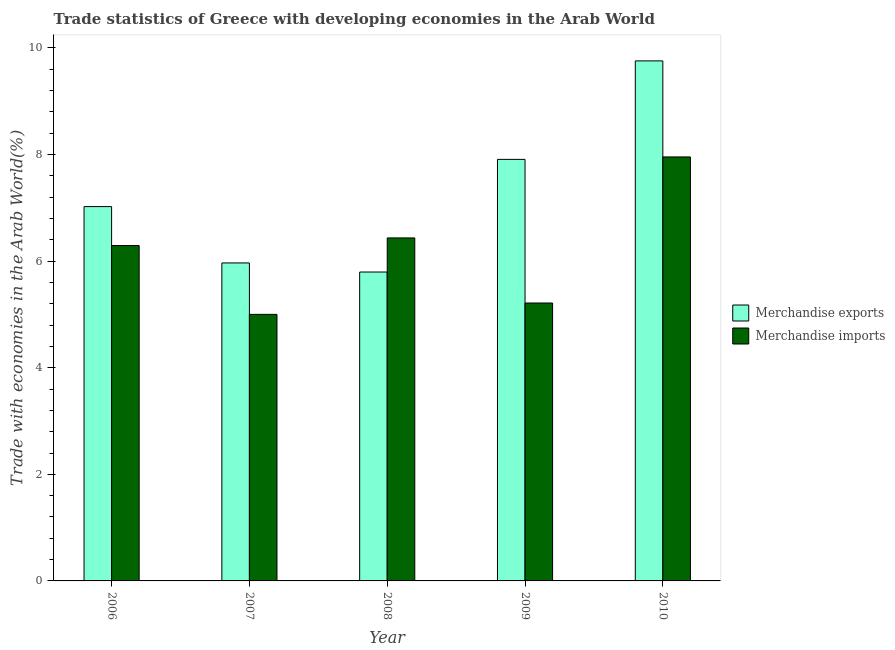How many bars are there on the 2nd tick from the right?
Offer a terse response. 2. What is the merchandise imports in 2006?
Your answer should be compact. 6.29. Across all years, what is the maximum merchandise imports?
Offer a terse response. 7.96. Across all years, what is the minimum merchandise exports?
Your answer should be compact. 5.8. In which year was the merchandise exports maximum?
Offer a very short reply. 2010. What is the total merchandise exports in the graph?
Offer a very short reply. 36.45. What is the difference between the merchandise imports in 2006 and that in 2007?
Provide a short and direct response. 1.29. What is the difference between the merchandise imports in 2006 and the merchandise exports in 2010?
Offer a very short reply. -1.66. What is the average merchandise imports per year?
Your answer should be very brief. 6.18. In the year 2006, what is the difference between the merchandise imports and merchandise exports?
Ensure brevity in your answer.  0. What is the ratio of the merchandise imports in 2006 to that in 2009?
Your answer should be very brief. 1.21. What is the difference between the highest and the second highest merchandise imports?
Offer a terse response. 1.52. What is the difference between the highest and the lowest merchandise exports?
Ensure brevity in your answer.  3.96. In how many years, is the merchandise imports greater than the average merchandise imports taken over all years?
Give a very brief answer. 3. Is the sum of the merchandise imports in 2006 and 2007 greater than the maximum merchandise exports across all years?
Your answer should be compact. Yes. What does the 2nd bar from the left in 2006 represents?
Offer a very short reply. Merchandise imports. What does the 1st bar from the right in 2008 represents?
Your answer should be compact. Merchandise imports. Are all the bars in the graph horizontal?
Keep it short and to the point. No. How many years are there in the graph?
Make the answer very short. 5. What is the difference between two consecutive major ticks on the Y-axis?
Your answer should be compact. 2. Does the graph contain grids?
Ensure brevity in your answer.  No. How are the legend labels stacked?
Your answer should be very brief. Vertical. What is the title of the graph?
Your answer should be very brief. Trade statistics of Greece with developing economies in the Arab World. What is the label or title of the X-axis?
Offer a terse response. Year. What is the label or title of the Y-axis?
Your answer should be very brief. Trade with economies in the Arab World(%). What is the Trade with economies in the Arab World(%) in Merchandise exports in 2006?
Your answer should be compact. 7.02. What is the Trade with economies in the Arab World(%) in Merchandise imports in 2006?
Offer a very short reply. 6.29. What is the Trade with economies in the Arab World(%) in Merchandise exports in 2007?
Your answer should be compact. 5.97. What is the Trade with economies in the Arab World(%) of Merchandise imports in 2007?
Provide a succinct answer. 5. What is the Trade with economies in the Arab World(%) of Merchandise exports in 2008?
Provide a succinct answer. 5.8. What is the Trade with economies in the Arab World(%) in Merchandise imports in 2008?
Your answer should be compact. 6.44. What is the Trade with economies in the Arab World(%) of Merchandise exports in 2009?
Give a very brief answer. 7.91. What is the Trade with economies in the Arab World(%) in Merchandise imports in 2009?
Offer a very short reply. 5.21. What is the Trade with economies in the Arab World(%) of Merchandise exports in 2010?
Your answer should be compact. 9.76. What is the Trade with economies in the Arab World(%) of Merchandise imports in 2010?
Offer a terse response. 7.96. Across all years, what is the maximum Trade with economies in the Arab World(%) of Merchandise exports?
Your answer should be very brief. 9.76. Across all years, what is the maximum Trade with economies in the Arab World(%) of Merchandise imports?
Give a very brief answer. 7.96. Across all years, what is the minimum Trade with economies in the Arab World(%) in Merchandise exports?
Provide a succinct answer. 5.8. Across all years, what is the minimum Trade with economies in the Arab World(%) in Merchandise imports?
Provide a short and direct response. 5. What is the total Trade with economies in the Arab World(%) in Merchandise exports in the graph?
Provide a succinct answer. 36.45. What is the total Trade with economies in the Arab World(%) of Merchandise imports in the graph?
Your answer should be compact. 30.9. What is the difference between the Trade with economies in the Arab World(%) of Merchandise exports in 2006 and that in 2007?
Your response must be concise. 1.06. What is the difference between the Trade with economies in the Arab World(%) of Merchandise imports in 2006 and that in 2007?
Make the answer very short. 1.29. What is the difference between the Trade with economies in the Arab World(%) in Merchandise exports in 2006 and that in 2008?
Offer a terse response. 1.23. What is the difference between the Trade with economies in the Arab World(%) in Merchandise imports in 2006 and that in 2008?
Ensure brevity in your answer.  -0.14. What is the difference between the Trade with economies in the Arab World(%) of Merchandise exports in 2006 and that in 2009?
Offer a very short reply. -0.89. What is the difference between the Trade with economies in the Arab World(%) of Merchandise imports in 2006 and that in 2009?
Give a very brief answer. 1.08. What is the difference between the Trade with economies in the Arab World(%) in Merchandise exports in 2006 and that in 2010?
Provide a short and direct response. -2.73. What is the difference between the Trade with economies in the Arab World(%) of Merchandise imports in 2006 and that in 2010?
Make the answer very short. -1.66. What is the difference between the Trade with economies in the Arab World(%) of Merchandise exports in 2007 and that in 2008?
Make the answer very short. 0.17. What is the difference between the Trade with economies in the Arab World(%) of Merchandise imports in 2007 and that in 2008?
Give a very brief answer. -1.43. What is the difference between the Trade with economies in the Arab World(%) in Merchandise exports in 2007 and that in 2009?
Provide a succinct answer. -1.94. What is the difference between the Trade with economies in the Arab World(%) of Merchandise imports in 2007 and that in 2009?
Give a very brief answer. -0.21. What is the difference between the Trade with economies in the Arab World(%) of Merchandise exports in 2007 and that in 2010?
Your answer should be very brief. -3.79. What is the difference between the Trade with economies in the Arab World(%) in Merchandise imports in 2007 and that in 2010?
Make the answer very short. -2.95. What is the difference between the Trade with economies in the Arab World(%) of Merchandise exports in 2008 and that in 2009?
Keep it short and to the point. -2.11. What is the difference between the Trade with economies in the Arab World(%) in Merchandise imports in 2008 and that in 2009?
Provide a succinct answer. 1.22. What is the difference between the Trade with economies in the Arab World(%) in Merchandise exports in 2008 and that in 2010?
Give a very brief answer. -3.96. What is the difference between the Trade with economies in the Arab World(%) of Merchandise imports in 2008 and that in 2010?
Keep it short and to the point. -1.52. What is the difference between the Trade with economies in the Arab World(%) in Merchandise exports in 2009 and that in 2010?
Your response must be concise. -1.85. What is the difference between the Trade with economies in the Arab World(%) in Merchandise imports in 2009 and that in 2010?
Provide a short and direct response. -2.74. What is the difference between the Trade with economies in the Arab World(%) of Merchandise exports in 2006 and the Trade with economies in the Arab World(%) of Merchandise imports in 2007?
Your answer should be compact. 2.02. What is the difference between the Trade with economies in the Arab World(%) in Merchandise exports in 2006 and the Trade with economies in the Arab World(%) in Merchandise imports in 2008?
Ensure brevity in your answer.  0.59. What is the difference between the Trade with economies in the Arab World(%) of Merchandise exports in 2006 and the Trade with economies in the Arab World(%) of Merchandise imports in 2009?
Provide a succinct answer. 1.81. What is the difference between the Trade with economies in the Arab World(%) in Merchandise exports in 2006 and the Trade with economies in the Arab World(%) in Merchandise imports in 2010?
Your answer should be compact. -0.93. What is the difference between the Trade with economies in the Arab World(%) of Merchandise exports in 2007 and the Trade with economies in the Arab World(%) of Merchandise imports in 2008?
Provide a short and direct response. -0.47. What is the difference between the Trade with economies in the Arab World(%) in Merchandise exports in 2007 and the Trade with economies in the Arab World(%) in Merchandise imports in 2009?
Your answer should be compact. 0.75. What is the difference between the Trade with economies in the Arab World(%) in Merchandise exports in 2007 and the Trade with economies in the Arab World(%) in Merchandise imports in 2010?
Give a very brief answer. -1.99. What is the difference between the Trade with economies in the Arab World(%) in Merchandise exports in 2008 and the Trade with economies in the Arab World(%) in Merchandise imports in 2009?
Ensure brevity in your answer.  0.58. What is the difference between the Trade with economies in the Arab World(%) of Merchandise exports in 2008 and the Trade with economies in the Arab World(%) of Merchandise imports in 2010?
Ensure brevity in your answer.  -2.16. What is the difference between the Trade with economies in the Arab World(%) in Merchandise exports in 2009 and the Trade with economies in the Arab World(%) in Merchandise imports in 2010?
Make the answer very short. -0.05. What is the average Trade with economies in the Arab World(%) in Merchandise exports per year?
Your response must be concise. 7.29. What is the average Trade with economies in the Arab World(%) in Merchandise imports per year?
Your answer should be very brief. 6.18. In the year 2006, what is the difference between the Trade with economies in the Arab World(%) of Merchandise exports and Trade with economies in the Arab World(%) of Merchandise imports?
Your response must be concise. 0.73. In the year 2007, what is the difference between the Trade with economies in the Arab World(%) of Merchandise exports and Trade with economies in the Arab World(%) of Merchandise imports?
Give a very brief answer. 0.96. In the year 2008, what is the difference between the Trade with economies in the Arab World(%) of Merchandise exports and Trade with economies in the Arab World(%) of Merchandise imports?
Your answer should be compact. -0.64. In the year 2009, what is the difference between the Trade with economies in the Arab World(%) in Merchandise exports and Trade with economies in the Arab World(%) in Merchandise imports?
Keep it short and to the point. 2.69. In the year 2010, what is the difference between the Trade with economies in the Arab World(%) of Merchandise exports and Trade with economies in the Arab World(%) of Merchandise imports?
Provide a short and direct response. 1.8. What is the ratio of the Trade with economies in the Arab World(%) of Merchandise exports in 2006 to that in 2007?
Your answer should be very brief. 1.18. What is the ratio of the Trade with economies in the Arab World(%) in Merchandise imports in 2006 to that in 2007?
Ensure brevity in your answer.  1.26. What is the ratio of the Trade with economies in the Arab World(%) in Merchandise exports in 2006 to that in 2008?
Offer a very short reply. 1.21. What is the ratio of the Trade with economies in the Arab World(%) of Merchandise imports in 2006 to that in 2008?
Your answer should be compact. 0.98. What is the ratio of the Trade with economies in the Arab World(%) in Merchandise exports in 2006 to that in 2009?
Give a very brief answer. 0.89. What is the ratio of the Trade with economies in the Arab World(%) of Merchandise imports in 2006 to that in 2009?
Provide a short and direct response. 1.21. What is the ratio of the Trade with economies in the Arab World(%) in Merchandise exports in 2006 to that in 2010?
Keep it short and to the point. 0.72. What is the ratio of the Trade with economies in the Arab World(%) in Merchandise imports in 2006 to that in 2010?
Provide a succinct answer. 0.79. What is the ratio of the Trade with economies in the Arab World(%) of Merchandise exports in 2007 to that in 2008?
Provide a succinct answer. 1.03. What is the ratio of the Trade with economies in the Arab World(%) of Merchandise imports in 2007 to that in 2008?
Your response must be concise. 0.78. What is the ratio of the Trade with economies in the Arab World(%) in Merchandise exports in 2007 to that in 2009?
Your answer should be compact. 0.75. What is the ratio of the Trade with economies in the Arab World(%) in Merchandise imports in 2007 to that in 2009?
Provide a short and direct response. 0.96. What is the ratio of the Trade with economies in the Arab World(%) of Merchandise exports in 2007 to that in 2010?
Your response must be concise. 0.61. What is the ratio of the Trade with economies in the Arab World(%) in Merchandise imports in 2007 to that in 2010?
Your response must be concise. 0.63. What is the ratio of the Trade with economies in the Arab World(%) of Merchandise exports in 2008 to that in 2009?
Your response must be concise. 0.73. What is the ratio of the Trade with economies in the Arab World(%) in Merchandise imports in 2008 to that in 2009?
Make the answer very short. 1.23. What is the ratio of the Trade with economies in the Arab World(%) of Merchandise exports in 2008 to that in 2010?
Your answer should be compact. 0.59. What is the ratio of the Trade with economies in the Arab World(%) of Merchandise imports in 2008 to that in 2010?
Keep it short and to the point. 0.81. What is the ratio of the Trade with economies in the Arab World(%) in Merchandise exports in 2009 to that in 2010?
Your response must be concise. 0.81. What is the ratio of the Trade with economies in the Arab World(%) of Merchandise imports in 2009 to that in 2010?
Offer a very short reply. 0.66. What is the difference between the highest and the second highest Trade with economies in the Arab World(%) of Merchandise exports?
Ensure brevity in your answer.  1.85. What is the difference between the highest and the second highest Trade with economies in the Arab World(%) in Merchandise imports?
Your answer should be compact. 1.52. What is the difference between the highest and the lowest Trade with economies in the Arab World(%) in Merchandise exports?
Offer a very short reply. 3.96. What is the difference between the highest and the lowest Trade with economies in the Arab World(%) of Merchandise imports?
Give a very brief answer. 2.95. 